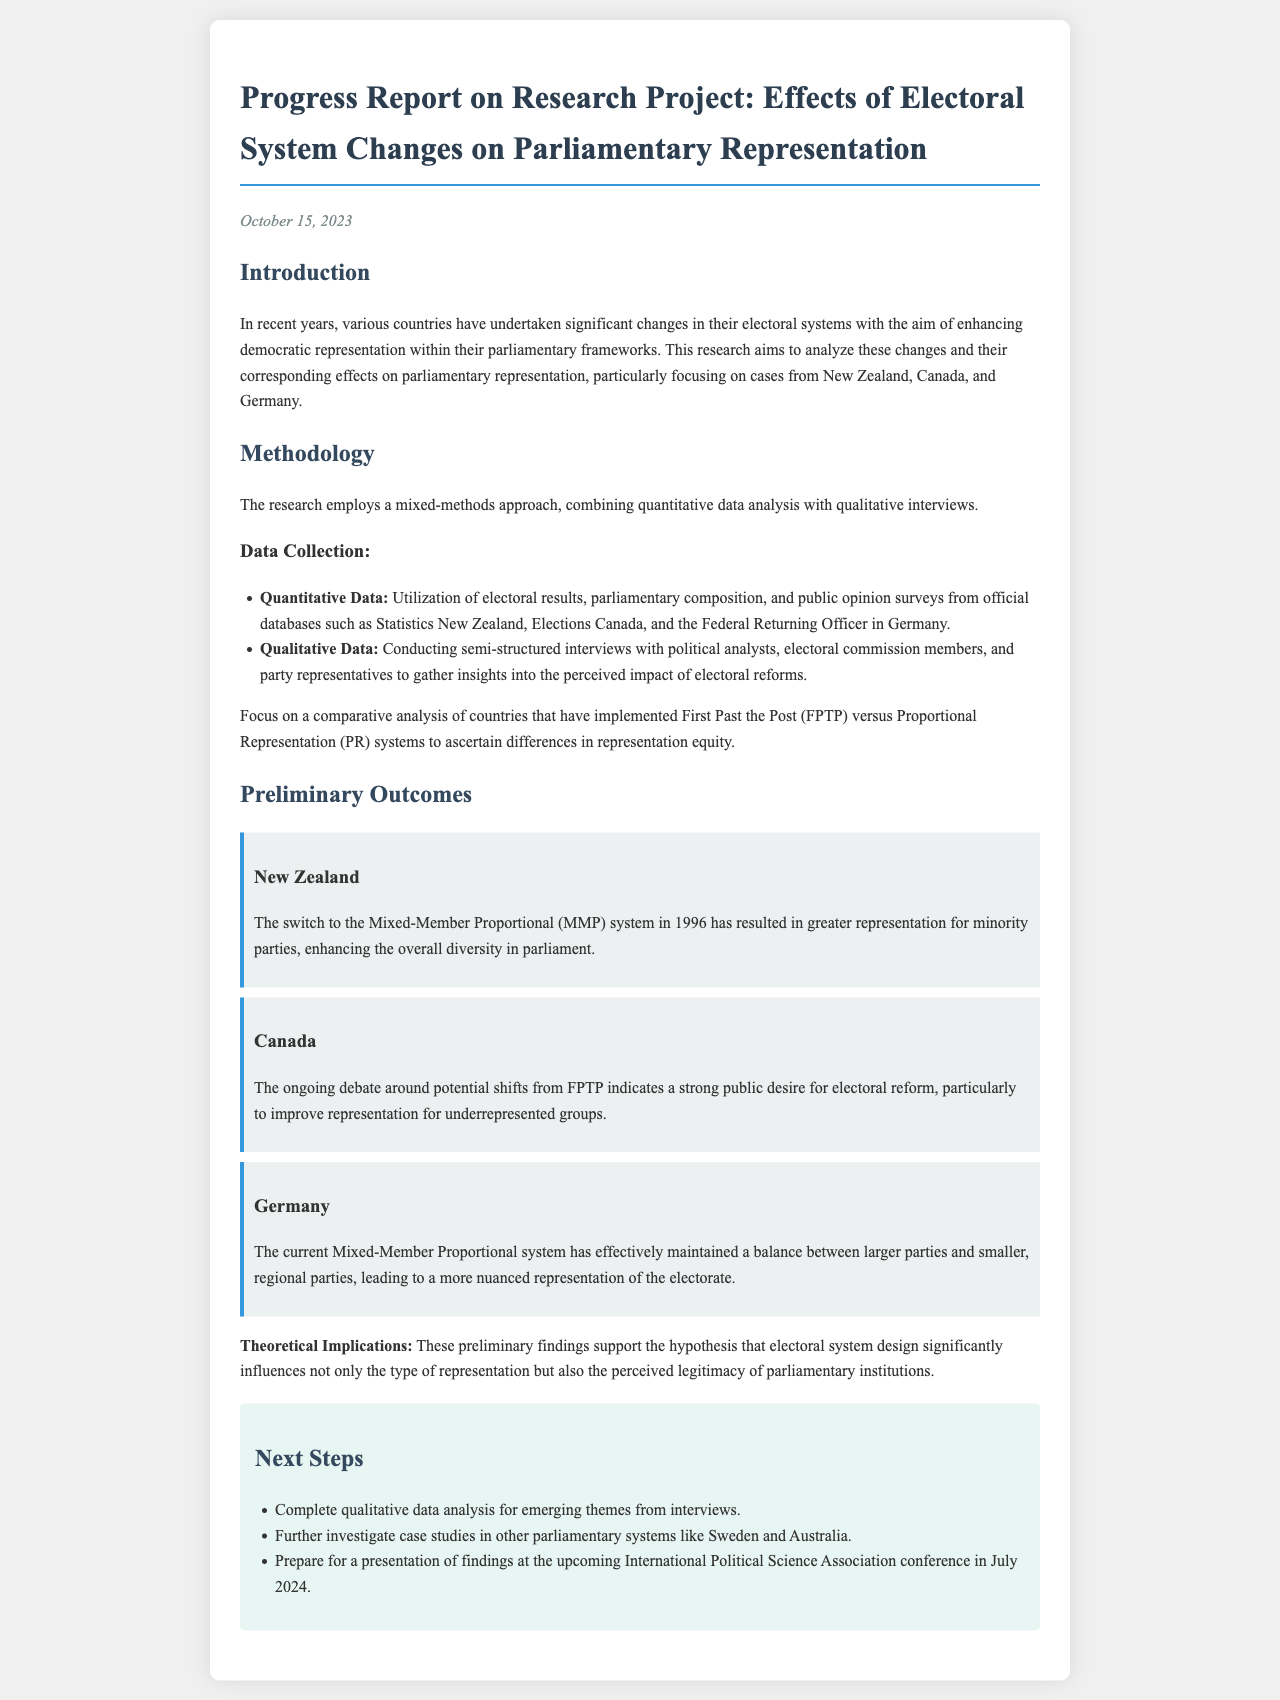What is the name of the research project? The title of the research project is provided in the header of the document.
Answer: Effects of Electoral System Changes on Parliamentary Representation What countries are focused on in the research? The introduction section lists the specific countries being studied for the research project.
Answer: New Zealand, Canada, Germany When did New Zealand switch to the MMP system? The preliminary outcome section specifies when New Zealand made the electoral system switch.
Answer: 1996 What method is used for qualitative data collection? The methodology section describes the method being employed for qualitative data collection.
Answer: Semi-structured interviews What significant outcome was observed in Germany regarding party representation? The preliminary outcomes section highlights the impact of the electoral system on party representation in Germany.
Answer: Balance between larger parties and smaller, regional parties What are the next steps outlined in the report? The next steps section lists what actions will be taken following the preliminary outcomes.
Answer: Complete qualitative data analysis What is the date of the progress report? The date is provided at the top of the document and signifies when the report was written.
Answer: October 15, 2023 How will the findings be presented? The next steps section mentions where the findings will be shared.
Answer: International Political Science Association conference 